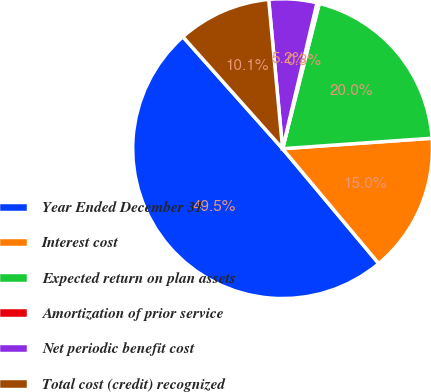<chart> <loc_0><loc_0><loc_500><loc_500><pie_chart><fcel>Year Ended December 31<fcel>Interest cost<fcel>Expected return on plan assets<fcel>Amortization of prior service<fcel>Net periodic benefit cost<fcel>Total cost (credit) recognized<nl><fcel>49.51%<fcel>15.02%<fcel>19.95%<fcel>0.25%<fcel>5.17%<fcel>10.1%<nl></chart> 